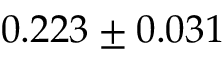Convert formula to latex. <formula><loc_0><loc_0><loc_500><loc_500>0 . 2 2 3 \pm 0 . 0 3 1</formula> 